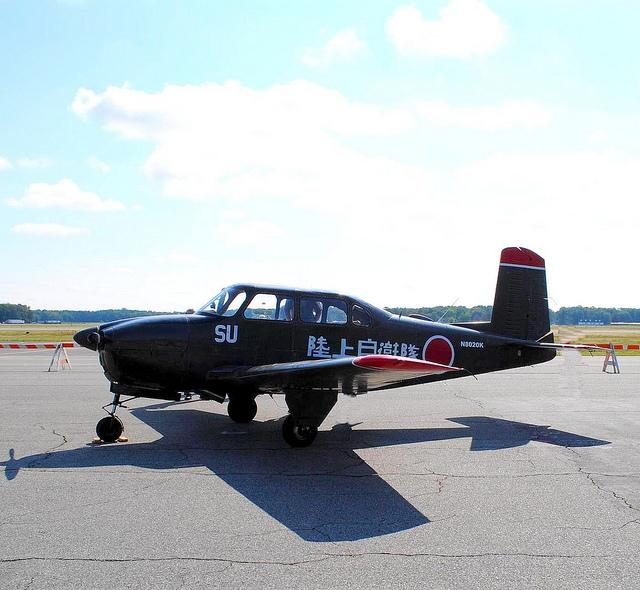How many wheels does the plane have?
Give a very brief answer. 3. Is this a jet plane?
Be succinct. No. What color is the dot on the plane?
Write a very short answer. Red. 